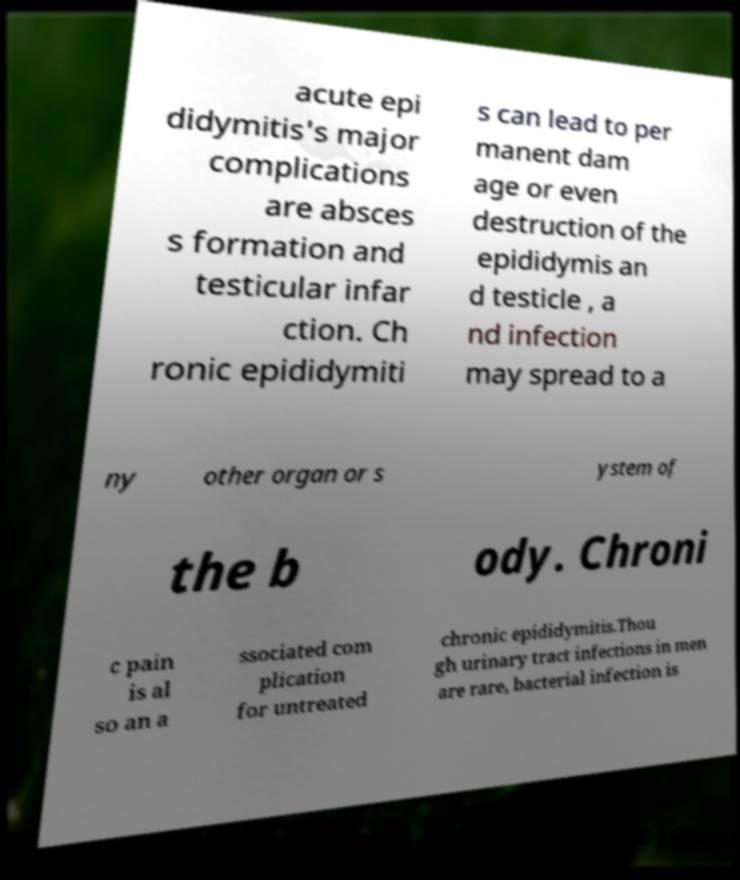For documentation purposes, I need the text within this image transcribed. Could you provide that? acute epi didymitis's major complications are absces s formation and testicular infar ction. Ch ronic epididymiti s can lead to per manent dam age or even destruction of the epididymis an d testicle , a nd infection may spread to a ny other organ or s ystem of the b ody. Chroni c pain is al so an a ssociated com plication for untreated chronic epididymitis.Thou gh urinary tract infections in men are rare, bacterial infection is 